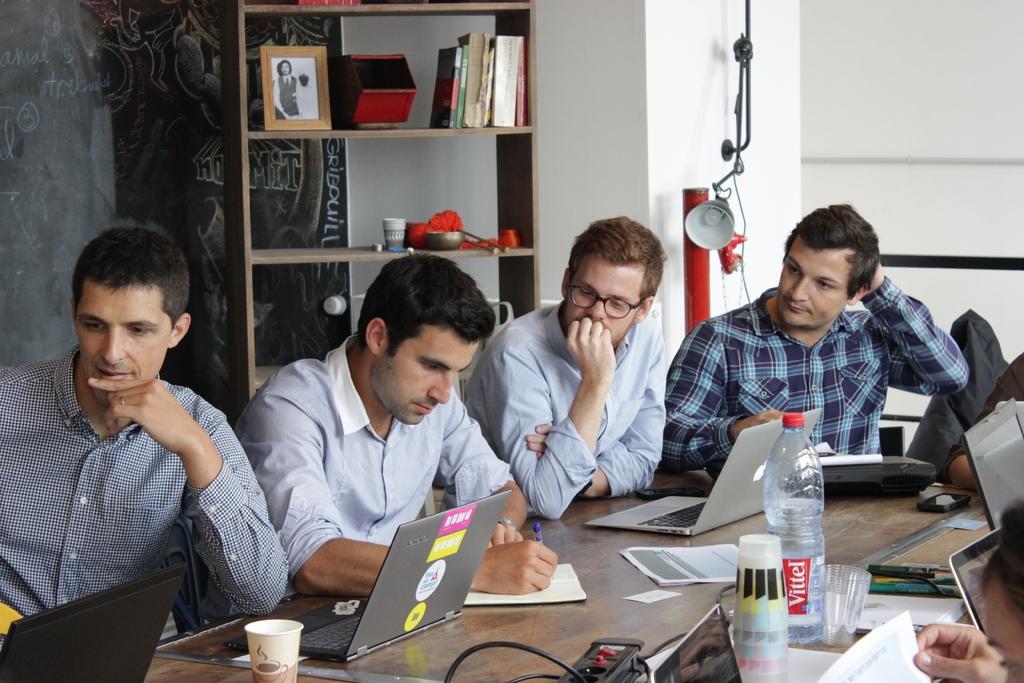Could you give a brief overview of what you see in this image? In the image we can see there are people sitting on the chairs and there are laptops, papers, glasses, water bottle, and extension box kept on the table. A person is holding pen in his hand and behind there is lamp kept on the wall. There are books kept in a rack and there is a black board on the wall. 